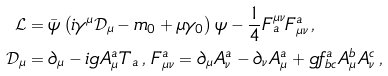Convert formula to latex. <formula><loc_0><loc_0><loc_500><loc_500>\mathcal { L } & = \bar { \psi } \left ( i \gamma ^ { \mu } \mathcal { D } _ { \mu } - m _ { 0 } + \mu \gamma _ { 0 } \right ) \psi - \frac { 1 } { 4 } F ^ { \mu \nu } _ { a } F _ { \mu \nu } ^ { a } \, , \\ \mathcal { D } _ { \mu } & = \partial _ { \mu } - i g A ^ { a } _ { \mu } T _ { a } \, , \, F _ { \mu \nu } ^ { a } = \partial _ { \mu } A ^ { a } _ { \nu } - \partial _ { \nu } A ^ { a } _ { \mu } + g f ^ { a } _ { b c } A ^ { b } _ { \mu } A ^ { c } _ { \nu } \, ,</formula> 